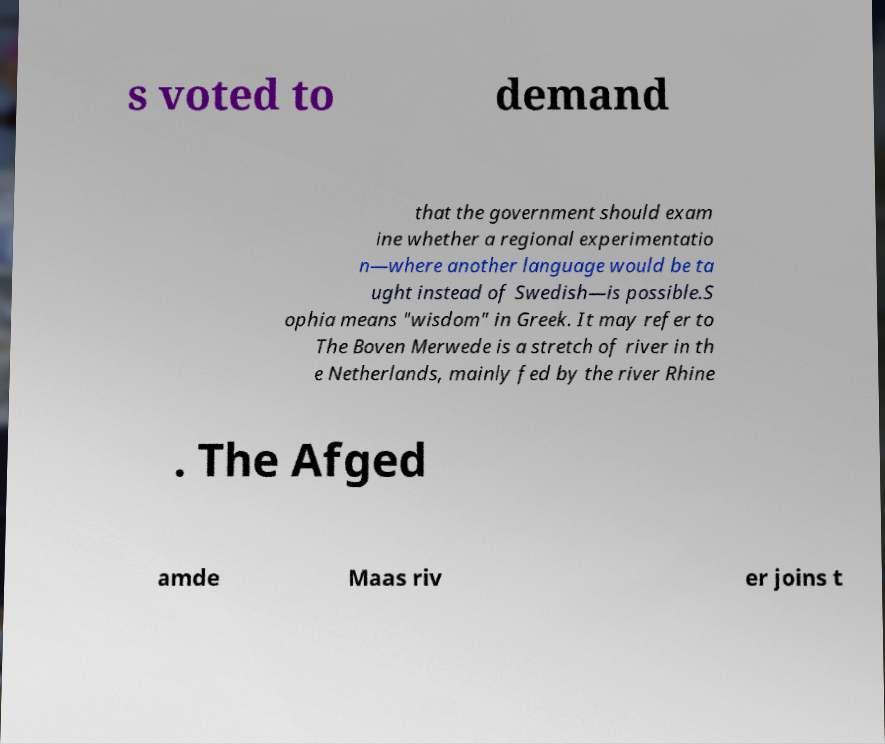Please read and relay the text visible in this image. What does it say? s voted to demand that the government should exam ine whether a regional experimentatio n—where another language would be ta ught instead of Swedish—is possible.S ophia means "wisdom" in Greek. It may refer to The Boven Merwede is a stretch of river in th e Netherlands, mainly fed by the river Rhine . The Afged amde Maas riv er joins t 